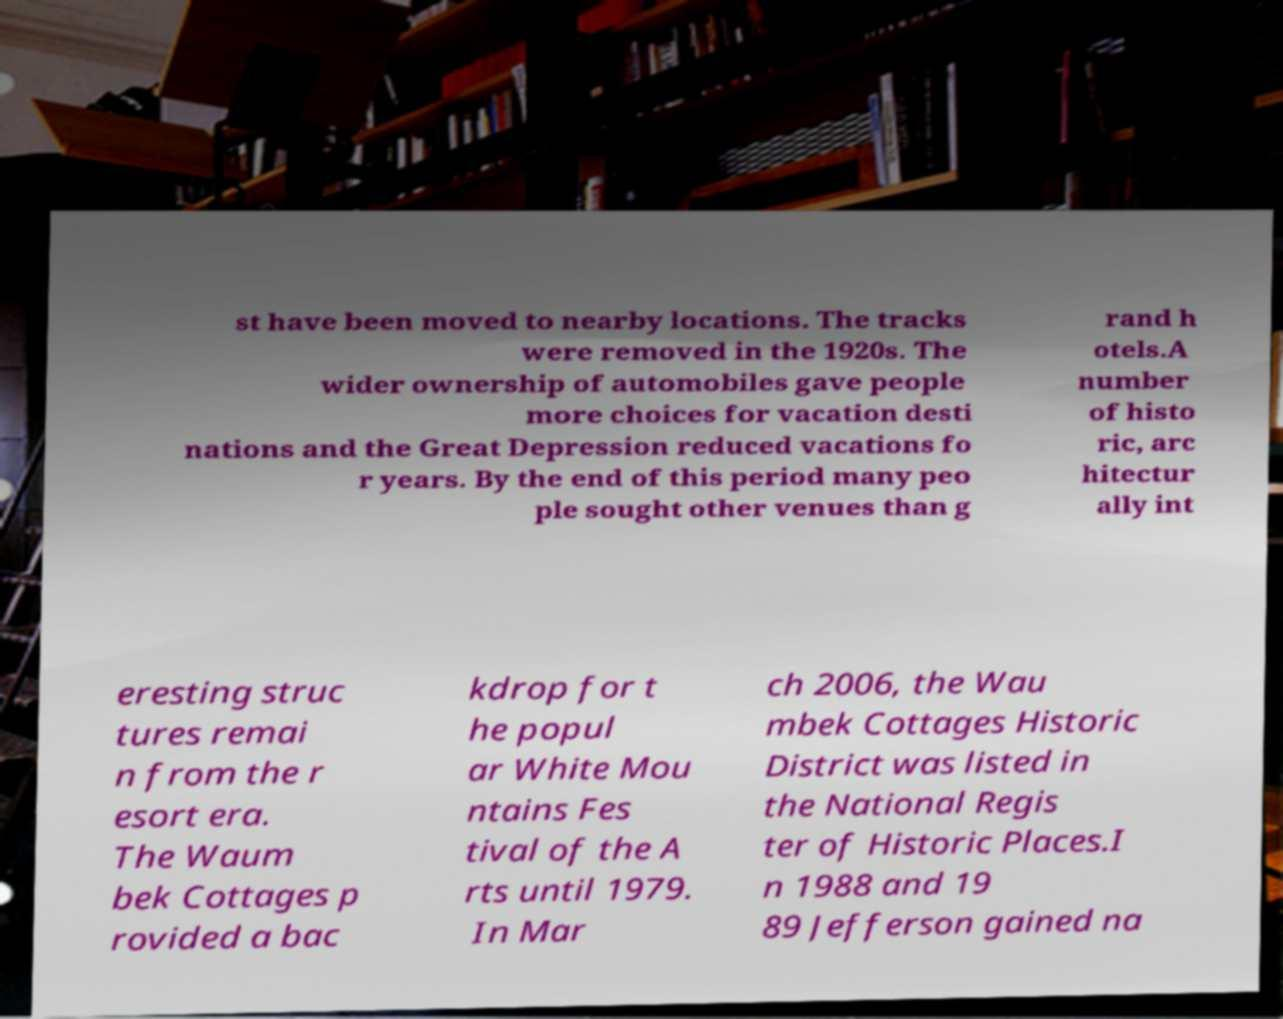There's text embedded in this image that I need extracted. Can you transcribe it verbatim? st have been moved to nearby locations. The tracks were removed in the 1920s. The wider ownership of automobiles gave people more choices for vacation desti nations and the Great Depression reduced vacations fo r years. By the end of this period many peo ple sought other venues than g rand h otels.A number of histo ric, arc hitectur ally int eresting struc tures remai n from the r esort era. The Waum bek Cottages p rovided a bac kdrop for t he popul ar White Mou ntains Fes tival of the A rts until 1979. In Mar ch 2006, the Wau mbek Cottages Historic District was listed in the National Regis ter of Historic Places.I n 1988 and 19 89 Jefferson gained na 